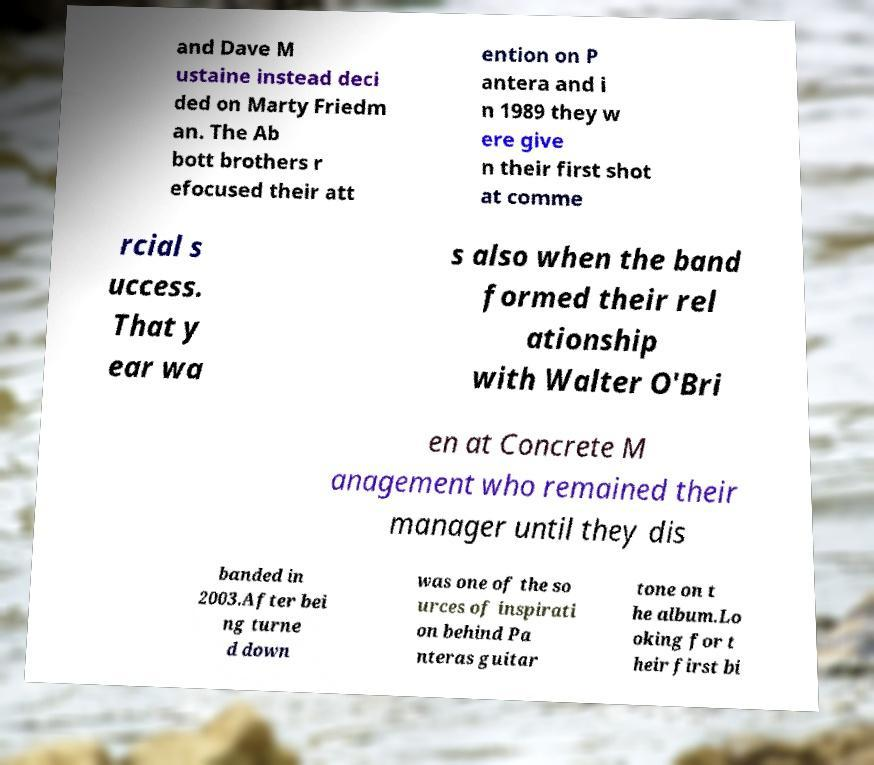Could you assist in decoding the text presented in this image and type it out clearly? and Dave M ustaine instead deci ded on Marty Friedm an. The Ab bott brothers r efocused their att ention on P antera and i n 1989 they w ere give n their first shot at comme rcial s uccess. That y ear wa s also when the band formed their rel ationship with Walter O'Bri en at Concrete M anagement who remained their manager until they dis banded in 2003.After bei ng turne d down was one of the so urces of inspirati on behind Pa nteras guitar tone on t he album.Lo oking for t heir first bi 